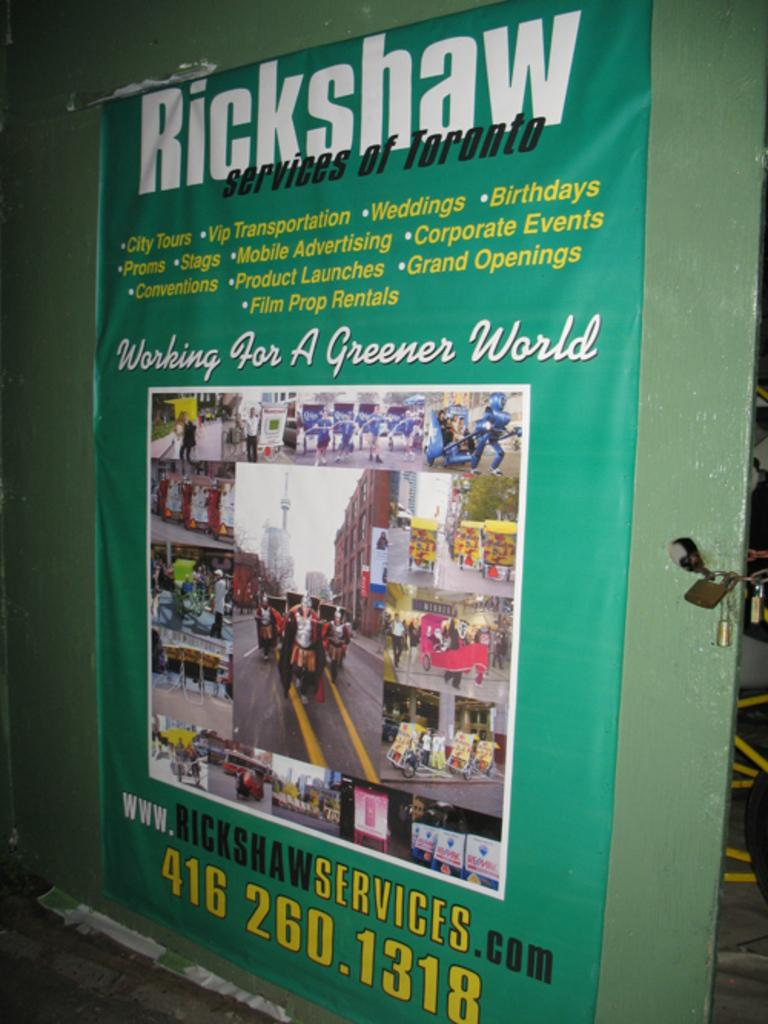Provide a one-sentence caption for the provided image. a poster advertising rickshaw services of Toronto canada. 